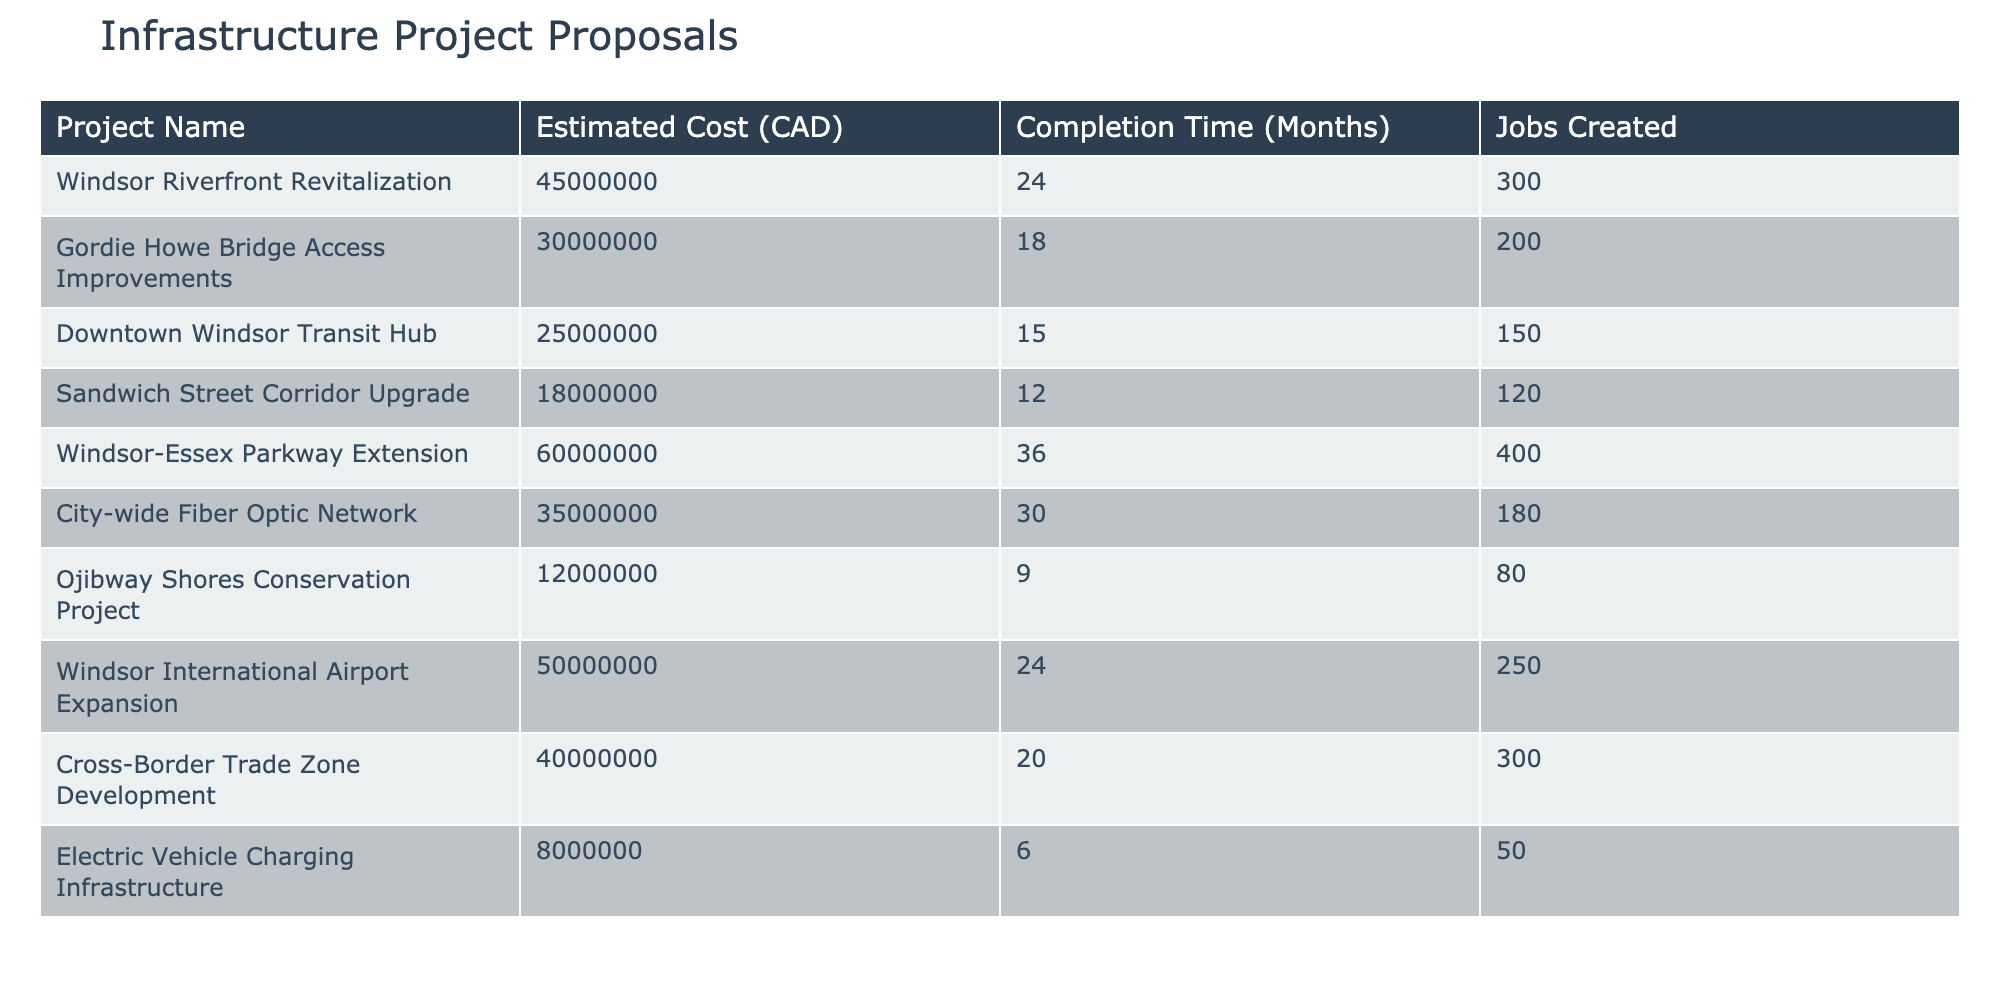What is the estimated cost of the Windsor Riverfront Revitalization project? From the table, the row for "Windsor Riverfront Revitalization" shows an estimated cost of 45,000,000 CAD.
Answer: 45,000,000 CAD How many jobs will the Downtown Windsor Transit Hub project create? Referring to the row for "Downtown Windsor Transit Hub," it states that the project will create 150 jobs.
Answer: 150 Which project has the shortest completion time, and how long is it? The project with the shortest completion time is "Electric Vehicle Charging Infrastructure," which has a completion time of 6 months.
Answer: Electric Vehicle Charging Infrastructure, 6 months What is the average estimated cost of all projects listed? To find the average cost, sum all the estimated costs: 45,000,000 + 30,000,000 + 25,000,000 + 18,000,000 + 60,000,000 + 35,000,000 + 12,000,000 + 50,000,000 + 40,000,000 + 8,000,000 = 353,000,000. There are 10 projects, so the average is 353,000,000 / 10 = 35,300,000.
Answer: 35,300,000 CAD Are there more projects that create over 200 jobs than those that create fewer than 100 jobs? The projects that create over 200 jobs are "Windsor Riverfront Revitalization" (300), "Gordie Howe Bridge Access Improvements" (200), "Windsor International Airport Expansion" (250), and "Cross-Border Trade Zone Development" (300), totaling 4. The projects creating fewer than 100 jobs are "Ojibway Shores Conservation Project" (80) and "Electric Vehicle Charging Infrastructure" (50), totaling 2. Since 4 is greater than 2, the answer is yes.
Answer: Yes Which project has the highest cost per job created? To calculate the cost per job for each project, divide the estimated cost by jobs created for each project. Checking these values, "Windsor-Essex Parkway Extension" has an estimated cost of 60,000,000 and creates 400 jobs, which is 150,000 per job, while "Ojibway Shores Conservation Project" has a cost of 12,000,000 for 80 jobs, which is 150,000 per job. The project with the highest cost per job is "Ojibway Shores Conservation Project" at 150,000 CAD per job.
Answer: Ojibway Shores Conservation Project How many projects have an estimated cost greater than 30 million CAD? By reviewing the table, the projects with costs greater than 30 million CAD are "Windsor Riverfront Revitalization," "Gordie Howe Bridge Access Improvements," "Windsor-Essex Parkway Extension," "City-wide Fiber Optic Network," "Windsor International Airport Expansion," and "Cross-Border Trade Zone Development." This totals 6 projects.
Answer: 6 